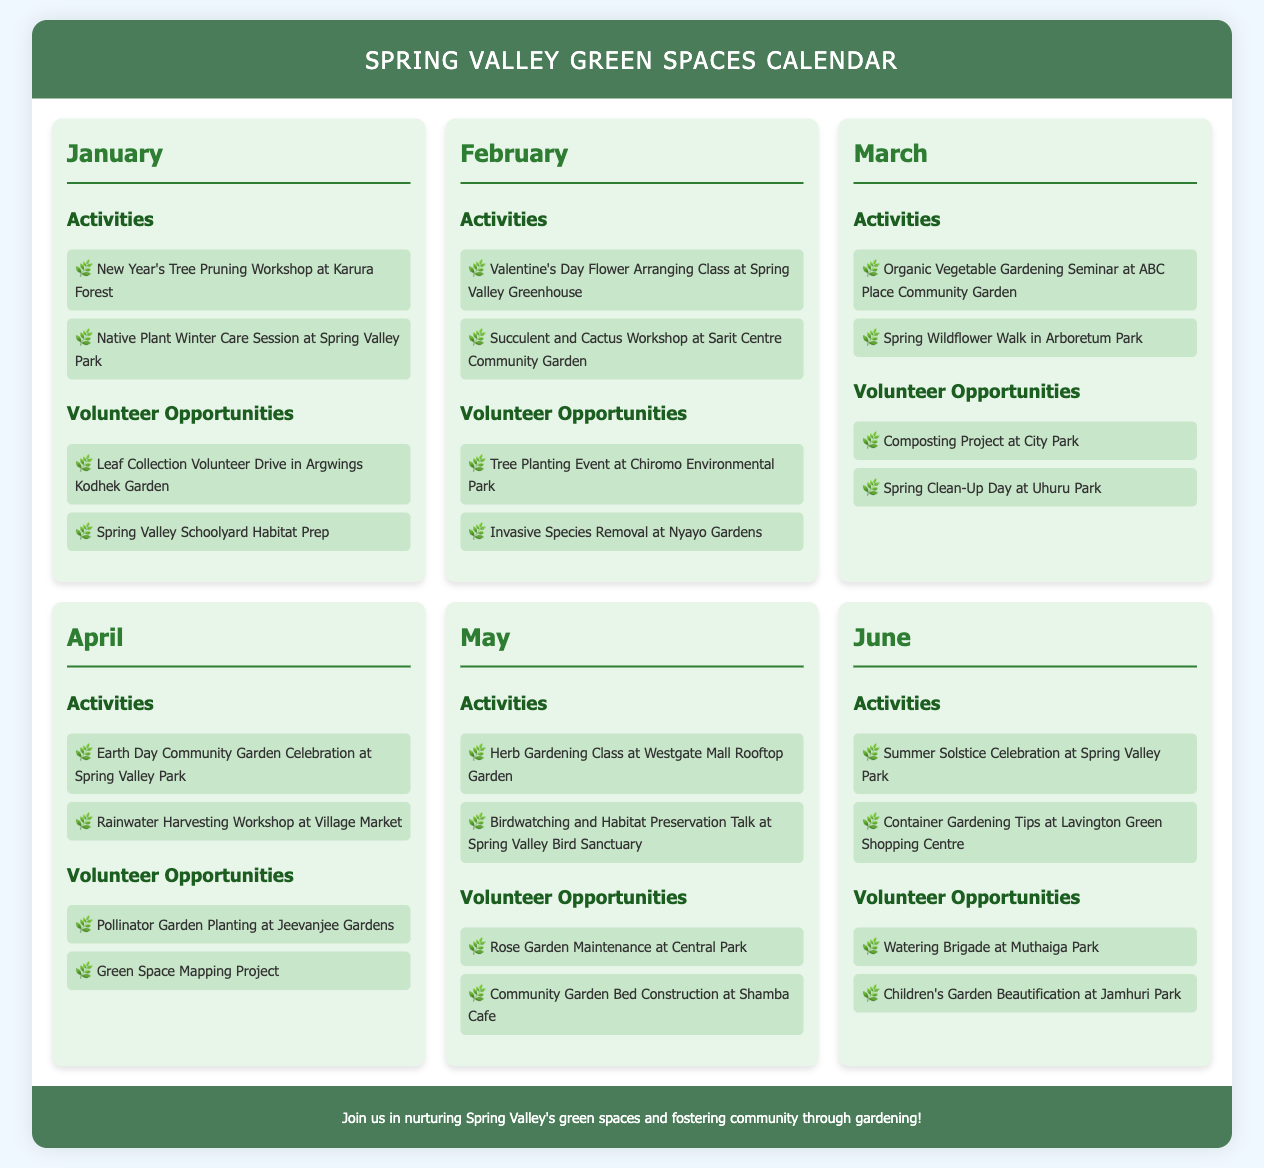what is the first activity listed for January? The first activity listed for January is "New Year's Tree Pruning Workshop at Karura Forest."
Answer: New Year's Tree Pruning Workshop at Karura Forest how many volunteer opportunities are there in February? There are two volunteer opportunities listed in February: "Tree Planting Event at Chiromo Environmental Park" and "Invasive Species Removal at Nyayo Gardens."
Answer: 2 which month has an event related to Earth Day? The month that has an event related to Earth Day is April, with the event "Earth Day Community Garden Celebration at Spring Valley Park."
Answer: April what type of workshop is scheduled for May? There are two workshops scheduled for May, one is "Herb Gardening Class" and the other is "Birdwatching and Habitat Preservation Talk."
Answer: Herb Gardening Class which park hosts the Summer Solstice Celebration? The park that hosts the Summer Solstice Celebration is Spring Valley Park.
Answer: Spring Valley Park what month features a workshop on rainwater harvesting? The month that features a workshop on rainwater harvesting is April, specifically at the Village Market.
Answer: April which volunteer opportunity involves children's activities? The volunteer opportunity that involves children's activities is "Children's Garden Beautification at Jamhuri Park."
Answer: Children's Garden Beautification at Jamhuri Park how many activities are planned for June? There are two activities planned for June: "Summer Solstice Celebration at Spring Valley Park" and "Container Gardening Tips at Lavington Green Shopping Centre."
Answer: 2 what is the theme of the activities in January? The theme of the activities in January revolves around tree care and native plant preservation.
Answer: tree care and native plant preservation 